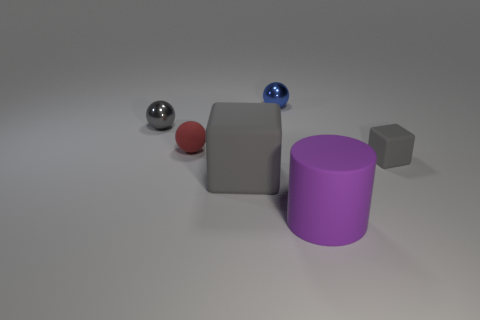How many other things are the same color as the rubber ball?
Offer a very short reply. 0. What color is the tiny thing that is in front of the tiny gray shiny thing and on the left side of the purple cylinder?
Offer a terse response. Red. What number of blocks are either large gray matte things or small gray objects?
Give a very brief answer. 2. What number of blue rubber objects are the same size as the gray shiny object?
Give a very brief answer. 0. There is a tiny shiny sphere that is to the right of the red thing; how many small gray things are on the right side of it?
Give a very brief answer. 1. There is a gray object that is both on the left side of the blue ball and right of the gray sphere; how big is it?
Your answer should be compact. Large. Are there more gray shiny things than large metal spheres?
Give a very brief answer. Yes. Is there a metal sphere of the same color as the rubber cylinder?
Make the answer very short. No. There is a gray block on the left side of the purple object; does it have the same size as the blue shiny sphere?
Ensure brevity in your answer.  No. Is the number of purple cubes less than the number of large objects?
Provide a succinct answer. Yes. 